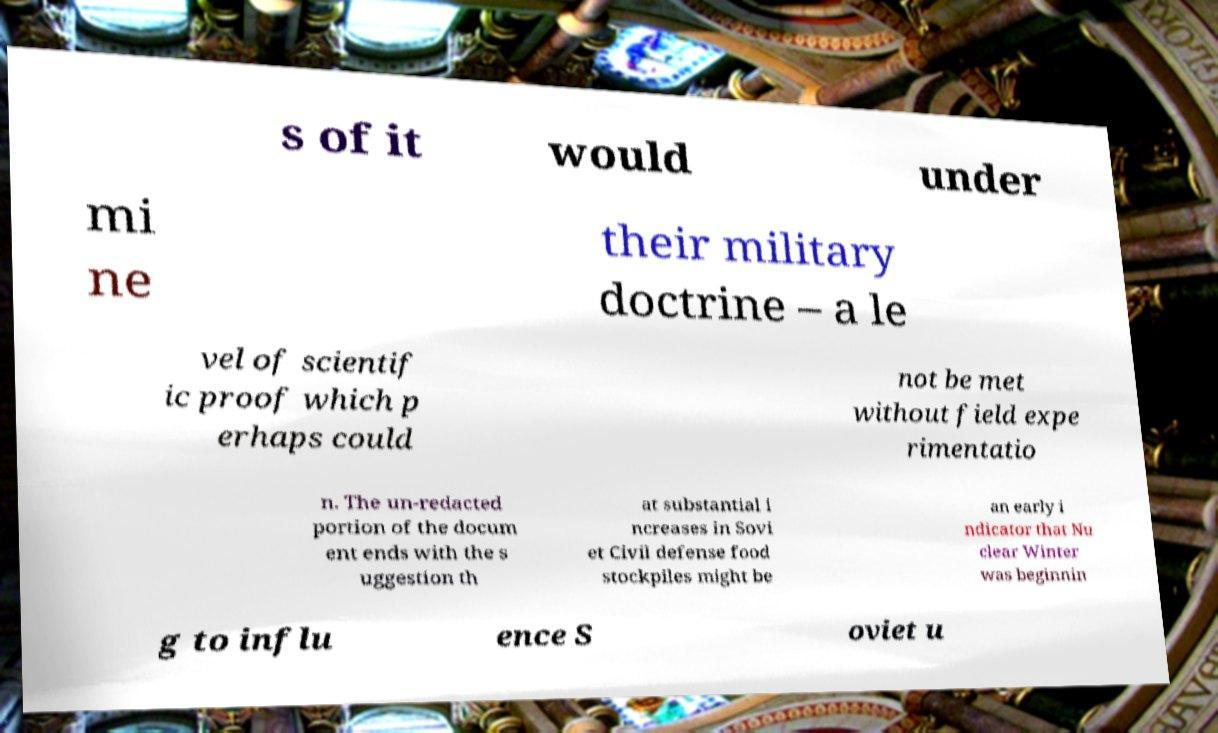Can you accurately transcribe the text from the provided image for me? s of it would under mi ne their military doctrine – a le vel of scientif ic proof which p erhaps could not be met without field expe rimentatio n. The un-redacted portion of the docum ent ends with the s uggestion th at substantial i ncreases in Sovi et Civil defense food stockpiles might be an early i ndicator that Nu clear Winter was beginnin g to influ ence S oviet u 